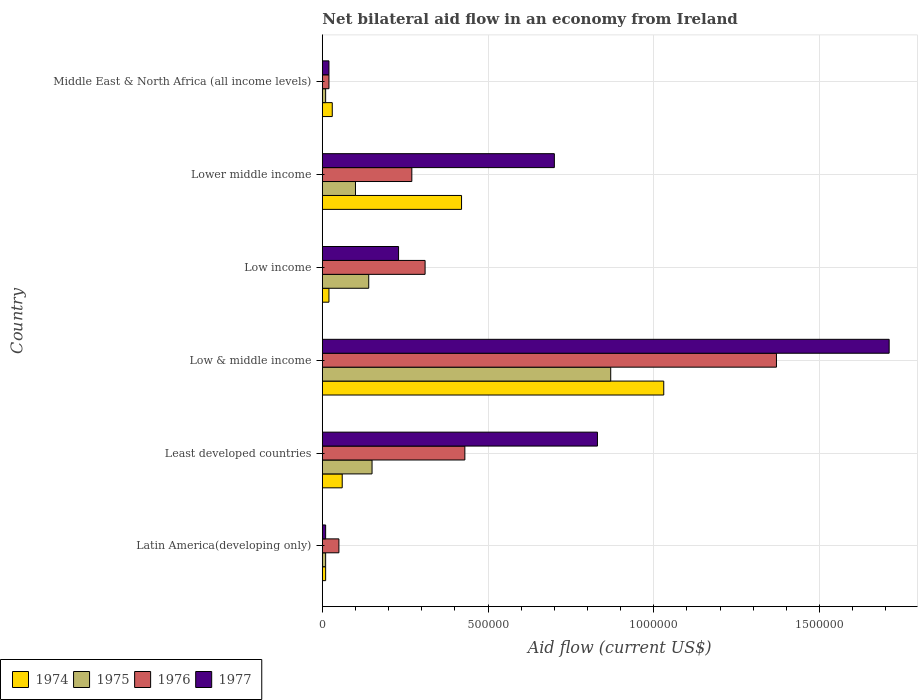How many different coloured bars are there?
Your response must be concise. 4. Are the number of bars per tick equal to the number of legend labels?
Your answer should be compact. Yes. How many bars are there on the 1st tick from the bottom?
Make the answer very short. 4. What is the label of the 1st group of bars from the top?
Keep it short and to the point. Middle East & North Africa (all income levels). In how many cases, is the number of bars for a given country not equal to the number of legend labels?
Offer a very short reply. 0. What is the net bilateral aid flow in 1976 in Middle East & North Africa (all income levels)?
Ensure brevity in your answer.  2.00e+04. Across all countries, what is the maximum net bilateral aid flow in 1975?
Keep it short and to the point. 8.70e+05. Across all countries, what is the minimum net bilateral aid flow in 1977?
Make the answer very short. 10000. In which country was the net bilateral aid flow in 1974 minimum?
Your answer should be compact. Latin America(developing only). What is the total net bilateral aid flow in 1976 in the graph?
Ensure brevity in your answer.  2.45e+06. What is the difference between the net bilateral aid flow in 1974 in Latin America(developing only) and that in Lower middle income?
Your response must be concise. -4.10e+05. What is the average net bilateral aid flow in 1975 per country?
Your answer should be compact. 2.13e+05. What is the difference between the net bilateral aid flow in 1974 and net bilateral aid flow in 1977 in Lower middle income?
Your answer should be very brief. -2.80e+05. In how many countries, is the net bilateral aid flow in 1976 greater than 400000 US$?
Provide a short and direct response. 2. What is the ratio of the net bilateral aid flow in 1974 in Low income to that in Lower middle income?
Make the answer very short. 0.05. Is the net bilateral aid flow in 1976 in Latin America(developing only) less than that in Low & middle income?
Your answer should be compact. Yes. What is the difference between the highest and the second highest net bilateral aid flow in 1977?
Your response must be concise. 8.80e+05. What is the difference between the highest and the lowest net bilateral aid flow in 1975?
Ensure brevity in your answer.  8.60e+05. In how many countries, is the net bilateral aid flow in 1976 greater than the average net bilateral aid flow in 1976 taken over all countries?
Your response must be concise. 2. Is it the case that in every country, the sum of the net bilateral aid flow in 1975 and net bilateral aid flow in 1977 is greater than the sum of net bilateral aid flow in 1976 and net bilateral aid flow in 1974?
Provide a succinct answer. No. What does the 2nd bar from the bottom in Latin America(developing only) represents?
Provide a short and direct response. 1975. How many bars are there?
Make the answer very short. 24. Are all the bars in the graph horizontal?
Your answer should be compact. Yes. What is the difference between two consecutive major ticks on the X-axis?
Your answer should be compact. 5.00e+05. Are the values on the major ticks of X-axis written in scientific E-notation?
Keep it short and to the point. No. Does the graph contain any zero values?
Make the answer very short. No. Does the graph contain grids?
Give a very brief answer. Yes. What is the title of the graph?
Provide a short and direct response. Net bilateral aid flow in an economy from Ireland. What is the label or title of the X-axis?
Make the answer very short. Aid flow (current US$). What is the Aid flow (current US$) of 1974 in Latin America(developing only)?
Provide a succinct answer. 10000. What is the Aid flow (current US$) in 1976 in Latin America(developing only)?
Ensure brevity in your answer.  5.00e+04. What is the Aid flow (current US$) of 1975 in Least developed countries?
Offer a terse response. 1.50e+05. What is the Aid flow (current US$) of 1977 in Least developed countries?
Offer a terse response. 8.30e+05. What is the Aid flow (current US$) in 1974 in Low & middle income?
Provide a succinct answer. 1.03e+06. What is the Aid flow (current US$) in 1975 in Low & middle income?
Offer a terse response. 8.70e+05. What is the Aid flow (current US$) in 1976 in Low & middle income?
Your response must be concise. 1.37e+06. What is the Aid flow (current US$) in 1977 in Low & middle income?
Keep it short and to the point. 1.71e+06. What is the Aid flow (current US$) of 1974 in Low income?
Offer a terse response. 2.00e+04. What is the Aid flow (current US$) of 1975 in Low income?
Provide a short and direct response. 1.40e+05. What is the Aid flow (current US$) in 1976 in Low income?
Offer a terse response. 3.10e+05. What is the Aid flow (current US$) in 1977 in Low income?
Your answer should be very brief. 2.30e+05. What is the Aid flow (current US$) in 1974 in Lower middle income?
Your answer should be very brief. 4.20e+05. What is the Aid flow (current US$) of 1975 in Lower middle income?
Your response must be concise. 1.00e+05. What is the Aid flow (current US$) of 1975 in Middle East & North Africa (all income levels)?
Your answer should be compact. 10000. What is the Aid flow (current US$) of 1976 in Middle East & North Africa (all income levels)?
Your response must be concise. 2.00e+04. Across all countries, what is the maximum Aid flow (current US$) in 1974?
Provide a succinct answer. 1.03e+06. Across all countries, what is the maximum Aid flow (current US$) of 1975?
Your answer should be compact. 8.70e+05. Across all countries, what is the maximum Aid flow (current US$) of 1976?
Your response must be concise. 1.37e+06. Across all countries, what is the maximum Aid flow (current US$) of 1977?
Ensure brevity in your answer.  1.71e+06. Across all countries, what is the minimum Aid flow (current US$) in 1974?
Provide a succinct answer. 10000. Across all countries, what is the minimum Aid flow (current US$) of 1976?
Provide a short and direct response. 2.00e+04. What is the total Aid flow (current US$) in 1974 in the graph?
Your response must be concise. 1.57e+06. What is the total Aid flow (current US$) of 1975 in the graph?
Provide a succinct answer. 1.28e+06. What is the total Aid flow (current US$) of 1976 in the graph?
Ensure brevity in your answer.  2.45e+06. What is the total Aid flow (current US$) of 1977 in the graph?
Your response must be concise. 3.50e+06. What is the difference between the Aid flow (current US$) in 1974 in Latin America(developing only) and that in Least developed countries?
Offer a very short reply. -5.00e+04. What is the difference between the Aid flow (current US$) of 1976 in Latin America(developing only) and that in Least developed countries?
Provide a succinct answer. -3.80e+05. What is the difference between the Aid flow (current US$) in 1977 in Latin America(developing only) and that in Least developed countries?
Offer a terse response. -8.20e+05. What is the difference between the Aid flow (current US$) of 1974 in Latin America(developing only) and that in Low & middle income?
Provide a succinct answer. -1.02e+06. What is the difference between the Aid flow (current US$) in 1975 in Latin America(developing only) and that in Low & middle income?
Offer a terse response. -8.60e+05. What is the difference between the Aid flow (current US$) of 1976 in Latin America(developing only) and that in Low & middle income?
Offer a terse response. -1.32e+06. What is the difference between the Aid flow (current US$) in 1977 in Latin America(developing only) and that in Low & middle income?
Offer a terse response. -1.70e+06. What is the difference between the Aid flow (current US$) of 1974 in Latin America(developing only) and that in Low income?
Offer a very short reply. -10000. What is the difference between the Aid flow (current US$) of 1974 in Latin America(developing only) and that in Lower middle income?
Your answer should be very brief. -4.10e+05. What is the difference between the Aid flow (current US$) of 1977 in Latin America(developing only) and that in Lower middle income?
Keep it short and to the point. -6.90e+05. What is the difference between the Aid flow (current US$) in 1975 in Latin America(developing only) and that in Middle East & North Africa (all income levels)?
Your response must be concise. 0. What is the difference between the Aid flow (current US$) in 1976 in Latin America(developing only) and that in Middle East & North Africa (all income levels)?
Provide a short and direct response. 3.00e+04. What is the difference between the Aid flow (current US$) of 1977 in Latin America(developing only) and that in Middle East & North Africa (all income levels)?
Offer a terse response. -10000. What is the difference between the Aid flow (current US$) of 1974 in Least developed countries and that in Low & middle income?
Give a very brief answer. -9.70e+05. What is the difference between the Aid flow (current US$) of 1975 in Least developed countries and that in Low & middle income?
Provide a succinct answer. -7.20e+05. What is the difference between the Aid flow (current US$) in 1976 in Least developed countries and that in Low & middle income?
Ensure brevity in your answer.  -9.40e+05. What is the difference between the Aid flow (current US$) of 1977 in Least developed countries and that in Low & middle income?
Offer a very short reply. -8.80e+05. What is the difference between the Aid flow (current US$) of 1975 in Least developed countries and that in Low income?
Provide a short and direct response. 10000. What is the difference between the Aid flow (current US$) in 1974 in Least developed countries and that in Lower middle income?
Your answer should be compact. -3.60e+05. What is the difference between the Aid flow (current US$) in 1976 in Least developed countries and that in Lower middle income?
Keep it short and to the point. 1.60e+05. What is the difference between the Aid flow (current US$) of 1977 in Least developed countries and that in Lower middle income?
Your answer should be compact. 1.30e+05. What is the difference between the Aid flow (current US$) of 1977 in Least developed countries and that in Middle East & North Africa (all income levels)?
Your response must be concise. 8.10e+05. What is the difference between the Aid flow (current US$) of 1974 in Low & middle income and that in Low income?
Make the answer very short. 1.01e+06. What is the difference between the Aid flow (current US$) of 1975 in Low & middle income and that in Low income?
Your response must be concise. 7.30e+05. What is the difference between the Aid flow (current US$) in 1976 in Low & middle income and that in Low income?
Keep it short and to the point. 1.06e+06. What is the difference between the Aid flow (current US$) of 1977 in Low & middle income and that in Low income?
Keep it short and to the point. 1.48e+06. What is the difference between the Aid flow (current US$) in 1975 in Low & middle income and that in Lower middle income?
Give a very brief answer. 7.70e+05. What is the difference between the Aid flow (current US$) in 1976 in Low & middle income and that in Lower middle income?
Offer a terse response. 1.10e+06. What is the difference between the Aid flow (current US$) in 1977 in Low & middle income and that in Lower middle income?
Keep it short and to the point. 1.01e+06. What is the difference between the Aid flow (current US$) in 1974 in Low & middle income and that in Middle East & North Africa (all income levels)?
Make the answer very short. 1.00e+06. What is the difference between the Aid flow (current US$) in 1975 in Low & middle income and that in Middle East & North Africa (all income levels)?
Your answer should be compact. 8.60e+05. What is the difference between the Aid flow (current US$) of 1976 in Low & middle income and that in Middle East & North Africa (all income levels)?
Ensure brevity in your answer.  1.35e+06. What is the difference between the Aid flow (current US$) of 1977 in Low & middle income and that in Middle East & North Africa (all income levels)?
Your response must be concise. 1.69e+06. What is the difference between the Aid flow (current US$) in 1974 in Low income and that in Lower middle income?
Provide a succinct answer. -4.00e+05. What is the difference between the Aid flow (current US$) of 1977 in Low income and that in Lower middle income?
Your answer should be very brief. -4.70e+05. What is the difference between the Aid flow (current US$) of 1974 in Low income and that in Middle East & North Africa (all income levels)?
Make the answer very short. -10000. What is the difference between the Aid flow (current US$) of 1976 in Low income and that in Middle East & North Africa (all income levels)?
Provide a succinct answer. 2.90e+05. What is the difference between the Aid flow (current US$) in 1975 in Lower middle income and that in Middle East & North Africa (all income levels)?
Offer a very short reply. 9.00e+04. What is the difference between the Aid flow (current US$) of 1976 in Lower middle income and that in Middle East & North Africa (all income levels)?
Provide a succinct answer. 2.50e+05. What is the difference between the Aid flow (current US$) of 1977 in Lower middle income and that in Middle East & North Africa (all income levels)?
Ensure brevity in your answer.  6.80e+05. What is the difference between the Aid flow (current US$) of 1974 in Latin America(developing only) and the Aid flow (current US$) of 1975 in Least developed countries?
Your response must be concise. -1.40e+05. What is the difference between the Aid flow (current US$) of 1974 in Latin America(developing only) and the Aid flow (current US$) of 1976 in Least developed countries?
Ensure brevity in your answer.  -4.20e+05. What is the difference between the Aid flow (current US$) in 1974 in Latin America(developing only) and the Aid flow (current US$) in 1977 in Least developed countries?
Your response must be concise. -8.20e+05. What is the difference between the Aid flow (current US$) of 1975 in Latin America(developing only) and the Aid flow (current US$) of 1976 in Least developed countries?
Ensure brevity in your answer.  -4.20e+05. What is the difference between the Aid flow (current US$) in 1975 in Latin America(developing only) and the Aid flow (current US$) in 1977 in Least developed countries?
Make the answer very short. -8.20e+05. What is the difference between the Aid flow (current US$) in 1976 in Latin America(developing only) and the Aid flow (current US$) in 1977 in Least developed countries?
Offer a terse response. -7.80e+05. What is the difference between the Aid flow (current US$) in 1974 in Latin America(developing only) and the Aid flow (current US$) in 1975 in Low & middle income?
Your answer should be very brief. -8.60e+05. What is the difference between the Aid flow (current US$) in 1974 in Latin America(developing only) and the Aid flow (current US$) in 1976 in Low & middle income?
Your answer should be very brief. -1.36e+06. What is the difference between the Aid flow (current US$) in 1974 in Latin America(developing only) and the Aid flow (current US$) in 1977 in Low & middle income?
Offer a terse response. -1.70e+06. What is the difference between the Aid flow (current US$) in 1975 in Latin America(developing only) and the Aid flow (current US$) in 1976 in Low & middle income?
Give a very brief answer. -1.36e+06. What is the difference between the Aid flow (current US$) in 1975 in Latin America(developing only) and the Aid flow (current US$) in 1977 in Low & middle income?
Your response must be concise. -1.70e+06. What is the difference between the Aid flow (current US$) of 1976 in Latin America(developing only) and the Aid flow (current US$) of 1977 in Low & middle income?
Give a very brief answer. -1.66e+06. What is the difference between the Aid flow (current US$) in 1974 in Latin America(developing only) and the Aid flow (current US$) in 1975 in Low income?
Provide a short and direct response. -1.30e+05. What is the difference between the Aid flow (current US$) in 1975 in Latin America(developing only) and the Aid flow (current US$) in 1976 in Low income?
Ensure brevity in your answer.  -3.00e+05. What is the difference between the Aid flow (current US$) in 1974 in Latin America(developing only) and the Aid flow (current US$) in 1975 in Lower middle income?
Keep it short and to the point. -9.00e+04. What is the difference between the Aid flow (current US$) of 1974 in Latin America(developing only) and the Aid flow (current US$) of 1977 in Lower middle income?
Provide a short and direct response. -6.90e+05. What is the difference between the Aid flow (current US$) of 1975 in Latin America(developing only) and the Aid flow (current US$) of 1977 in Lower middle income?
Give a very brief answer. -6.90e+05. What is the difference between the Aid flow (current US$) in 1976 in Latin America(developing only) and the Aid flow (current US$) in 1977 in Lower middle income?
Ensure brevity in your answer.  -6.50e+05. What is the difference between the Aid flow (current US$) of 1974 in Latin America(developing only) and the Aid flow (current US$) of 1976 in Middle East & North Africa (all income levels)?
Your response must be concise. -10000. What is the difference between the Aid flow (current US$) in 1974 in Latin America(developing only) and the Aid flow (current US$) in 1977 in Middle East & North Africa (all income levels)?
Your answer should be very brief. -10000. What is the difference between the Aid flow (current US$) in 1975 in Latin America(developing only) and the Aid flow (current US$) in 1976 in Middle East & North Africa (all income levels)?
Ensure brevity in your answer.  -10000. What is the difference between the Aid flow (current US$) of 1975 in Latin America(developing only) and the Aid flow (current US$) of 1977 in Middle East & North Africa (all income levels)?
Your answer should be compact. -10000. What is the difference between the Aid flow (current US$) of 1976 in Latin America(developing only) and the Aid flow (current US$) of 1977 in Middle East & North Africa (all income levels)?
Ensure brevity in your answer.  3.00e+04. What is the difference between the Aid flow (current US$) in 1974 in Least developed countries and the Aid flow (current US$) in 1975 in Low & middle income?
Keep it short and to the point. -8.10e+05. What is the difference between the Aid flow (current US$) in 1974 in Least developed countries and the Aid flow (current US$) in 1976 in Low & middle income?
Offer a terse response. -1.31e+06. What is the difference between the Aid flow (current US$) of 1974 in Least developed countries and the Aid flow (current US$) of 1977 in Low & middle income?
Offer a very short reply. -1.65e+06. What is the difference between the Aid flow (current US$) of 1975 in Least developed countries and the Aid flow (current US$) of 1976 in Low & middle income?
Provide a short and direct response. -1.22e+06. What is the difference between the Aid flow (current US$) of 1975 in Least developed countries and the Aid flow (current US$) of 1977 in Low & middle income?
Your answer should be very brief. -1.56e+06. What is the difference between the Aid flow (current US$) of 1976 in Least developed countries and the Aid flow (current US$) of 1977 in Low & middle income?
Your answer should be compact. -1.28e+06. What is the difference between the Aid flow (current US$) in 1974 in Least developed countries and the Aid flow (current US$) in 1976 in Low income?
Offer a very short reply. -2.50e+05. What is the difference between the Aid flow (current US$) of 1975 in Least developed countries and the Aid flow (current US$) of 1976 in Low income?
Your answer should be very brief. -1.60e+05. What is the difference between the Aid flow (current US$) of 1974 in Least developed countries and the Aid flow (current US$) of 1975 in Lower middle income?
Your answer should be very brief. -4.00e+04. What is the difference between the Aid flow (current US$) in 1974 in Least developed countries and the Aid flow (current US$) in 1976 in Lower middle income?
Keep it short and to the point. -2.10e+05. What is the difference between the Aid flow (current US$) of 1974 in Least developed countries and the Aid flow (current US$) of 1977 in Lower middle income?
Provide a short and direct response. -6.40e+05. What is the difference between the Aid flow (current US$) of 1975 in Least developed countries and the Aid flow (current US$) of 1976 in Lower middle income?
Offer a terse response. -1.20e+05. What is the difference between the Aid flow (current US$) in 1975 in Least developed countries and the Aid flow (current US$) in 1977 in Lower middle income?
Provide a succinct answer. -5.50e+05. What is the difference between the Aid flow (current US$) of 1976 in Least developed countries and the Aid flow (current US$) of 1977 in Lower middle income?
Provide a short and direct response. -2.70e+05. What is the difference between the Aid flow (current US$) of 1974 in Least developed countries and the Aid flow (current US$) of 1976 in Middle East & North Africa (all income levels)?
Your response must be concise. 4.00e+04. What is the difference between the Aid flow (current US$) in 1974 in Least developed countries and the Aid flow (current US$) in 1977 in Middle East & North Africa (all income levels)?
Make the answer very short. 4.00e+04. What is the difference between the Aid flow (current US$) in 1976 in Least developed countries and the Aid flow (current US$) in 1977 in Middle East & North Africa (all income levels)?
Make the answer very short. 4.10e+05. What is the difference between the Aid flow (current US$) in 1974 in Low & middle income and the Aid flow (current US$) in 1975 in Low income?
Your answer should be very brief. 8.90e+05. What is the difference between the Aid flow (current US$) in 1974 in Low & middle income and the Aid flow (current US$) in 1976 in Low income?
Keep it short and to the point. 7.20e+05. What is the difference between the Aid flow (current US$) of 1975 in Low & middle income and the Aid flow (current US$) of 1976 in Low income?
Your answer should be compact. 5.60e+05. What is the difference between the Aid flow (current US$) in 1975 in Low & middle income and the Aid flow (current US$) in 1977 in Low income?
Your response must be concise. 6.40e+05. What is the difference between the Aid flow (current US$) of 1976 in Low & middle income and the Aid flow (current US$) of 1977 in Low income?
Make the answer very short. 1.14e+06. What is the difference between the Aid flow (current US$) in 1974 in Low & middle income and the Aid flow (current US$) in 1975 in Lower middle income?
Provide a succinct answer. 9.30e+05. What is the difference between the Aid flow (current US$) of 1974 in Low & middle income and the Aid flow (current US$) of 1976 in Lower middle income?
Give a very brief answer. 7.60e+05. What is the difference between the Aid flow (current US$) in 1974 in Low & middle income and the Aid flow (current US$) in 1977 in Lower middle income?
Offer a very short reply. 3.30e+05. What is the difference between the Aid flow (current US$) in 1975 in Low & middle income and the Aid flow (current US$) in 1976 in Lower middle income?
Ensure brevity in your answer.  6.00e+05. What is the difference between the Aid flow (current US$) of 1976 in Low & middle income and the Aid flow (current US$) of 1977 in Lower middle income?
Provide a short and direct response. 6.70e+05. What is the difference between the Aid flow (current US$) of 1974 in Low & middle income and the Aid flow (current US$) of 1975 in Middle East & North Africa (all income levels)?
Give a very brief answer. 1.02e+06. What is the difference between the Aid flow (current US$) of 1974 in Low & middle income and the Aid flow (current US$) of 1976 in Middle East & North Africa (all income levels)?
Offer a very short reply. 1.01e+06. What is the difference between the Aid flow (current US$) of 1974 in Low & middle income and the Aid flow (current US$) of 1977 in Middle East & North Africa (all income levels)?
Your answer should be very brief. 1.01e+06. What is the difference between the Aid flow (current US$) in 1975 in Low & middle income and the Aid flow (current US$) in 1976 in Middle East & North Africa (all income levels)?
Provide a succinct answer. 8.50e+05. What is the difference between the Aid flow (current US$) in 1975 in Low & middle income and the Aid flow (current US$) in 1977 in Middle East & North Africa (all income levels)?
Provide a succinct answer. 8.50e+05. What is the difference between the Aid flow (current US$) in 1976 in Low & middle income and the Aid flow (current US$) in 1977 in Middle East & North Africa (all income levels)?
Offer a terse response. 1.35e+06. What is the difference between the Aid flow (current US$) of 1974 in Low income and the Aid flow (current US$) of 1977 in Lower middle income?
Give a very brief answer. -6.80e+05. What is the difference between the Aid flow (current US$) of 1975 in Low income and the Aid flow (current US$) of 1976 in Lower middle income?
Your answer should be very brief. -1.30e+05. What is the difference between the Aid flow (current US$) of 1975 in Low income and the Aid flow (current US$) of 1977 in Lower middle income?
Provide a short and direct response. -5.60e+05. What is the difference between the Aid flow (current US$) in 1976 in Low income and the Aid flow (current US$) in 1977 in Lower middle income?
Your answer should be compact. -3.90e+05. What is the difference between the Aid flow (current US$) of 1974 in Low income and the Aid flow (current US$) of 1975 in Middle East & North Africa (all income levels)?
Ensure brevity in your answer.  10000. What is the difference between the Aid flow (current US$) in 1974 in Low income and the Aid flow (current US$) in 1976 in Middle East & North Africa (all income levels)?
Keep it short and to the point. 0. What is the difference between the Aid flow (current US$) of 1974 in Low income and the Aid flow (current US$) of 1977 in Middle East & North Africa (all income levels)?
Keep it short and to the point. 0. What is the difference between the Aid flow (current US$) of 1975 in Low income and the Aid flow (current US$) of 1976 in Middle East & North Africa (all income levels)?
Give a very brief answer. 1.20e+05. What is the difference between the Aid flow (current US$) in 1976 in Low income and the Aid flow (current US$) in 1977 in Middle East & North Africa (all income levels)?
Your answer should be compact. 2.90e+05. What is the difference between the Aid flow (current US$) in 1974 in Lower middle income and the Aid flow (current US$) in 1977 in Middle East & North Africa (all income levels)?
Your answer should be very brief. 4.00e+05. What is the difference between the Aid flow (current US$) of 1975 in Lower middle income and the Aid flow (current US$) of 1976 in Middle East & North Africa (all income levels)?
Make the answer very short. 8.00e+04. What is the average Aid flow (current US$) of 1974 per country?
Give a very brief answer. 2.62e+05. What is the average Aid flow (current US$) in 1975 per country?
Your answer should be very brief. 2.13e+05. What is the average Aid flow (current US$) in 1976 per country?
Provide a succinct answer. 4.08e+05. What is the average Aid flow (current US$) of 1977 per country?
Provide a short and direct response. 5.83e+05. What is the difference between the Aid flow (current US$) of 1974 and Aid flow (current US$) of 1976 in Latin America(developing only)?
Offer a very short reply. -4.00e+04. What is the difference between the Aid flow (current US$) in 1974 and Aid flow (current US$) in 1977 in Latin America(developing only)?
Ensure brevity in your answer.  0. What is the difference between the Aid flow (current US$) in 1976 and Aid flow (current US$) in 1977 in Latin America(developing only)?
Provide a succinct answer. 4.00e+04. What is the difference between the Aid flow (current US$) in 1974 and Aid flow (current US$) in 1975 in Least developed countries?
Offer a very short reply. -9.00e+04. What is the difference between the Aid flow (current US$) of 1974 and Aid flow (current US$) of 1976 in Least developed countries?
Keep it short and to the point. -3.70e+05. What is the difference between the Aid flow (current US$) in 1974 and Aid flow (current US$) in 1977 in Least developed countries?
Offer a very short reply. -7.70e+05. What is the difference between the Aid flow (current US$) of 1975 and Aid flow (current US$) of 1976 in Least developed countries?
Provide a short and direct response. -2.80e+05. What is the difference between the Aid flow (current US$) of 1975 and Aid flow (current US$) of 1977 in Least developed countries?
Ensure brevity in your answer.  -6.80e+05. What is the difference between the Aid flow (current US$) in 1976 and Aid flow (current US$) in 1977 in Least developed countries?
Your answer should be very brief. -4.00e+05. What is the difference between the Aid flow (current US$) of 1974 and Aid flow (current US$) of 1975 in Low & middle income?
Your response must be concise. 1.60e+05. What is the difference between the Aid flow (current US$) of 1974 and Aid flow (current US$) of 1977 in Low & middle income?
Your answer should be very brief. -6.80e+05. What is the difference between the Aid flow (current US$) in 1975 and Aid flow (current US$) in 1976 in Low & middle income?
Keep it short and to the point. -5.00e+05. What is the difference between the Aid flow (current US$) of 1975 and Aid flow (current US$) of 1977 in Low & middle income?
Keep it short and to the point. -8.40e+05. What is the difference between the Aid flow (current US$) in 1974 and Aid flow (current US$) in 1975 in Low income?
Ensure brevity in your answer.  -1.20e+05. What is the difference between the Aid flow (current US$) of 1975 and Aid flow (current US$) of 1976 in Low income?
Offer a very short reply. -1.70e+05. What is the difference between the Aid flow (current US$) of 1975 and Aid flow (current US$) of 1977 in Low income?
Provide a short and direct response. -9.00e+04. What is the difference between the Aid flow (current US$) in 1976 and Aid flow (current US$) in 1977 in Low income?
Your response must be concise. 8.00e+04. What is the difference between the Aid flow (current US$) of 1974 and Aid flow (current US$) of 1975 in Lower middle income?
Your answer should be very brief. 3.20e+05. What is the difference between the Aid flow (current US$) in 1974 and Aid flow (current US$) in 1976 in Lower middle income?
Ensure brevity in your answer.  1.50e+05. What is the difference between the Aid flow (current US$) of 1974 and Aid flow (current US$) of 1977 in Lower middle income?
Keep it short and to the point. -2.80e+05. What is the difference between the Aid flow (current US$) of 1975 and Aid flow (current US$) of 1976 in Lower middle income?
Make the answer very short. -1.70e+05. What is the difference between the Aid flow (current US$) of 1975 and Aid flow (current US$) of 1977 in Lower middle income?
Ensure brevity in your answer.  -6.00e+05. What is the difference between the Aid flow (current US$) in 1976 and Aid flow (current US$) in 1977 in Lower middle income?
Your answer should be compact. -4.30e+05. What is the difference between the Aid flow (current US$) in 1974 and Aid flow (current US$) in 1977 in Middle East & North Africa (all income levels)?
Offer a very short reply. 10000. What is the difference between the Aid flow (current US$) of 1976 and Aid flow (current US$) of 1977 in Middle East & North Africa (all income levels)?
Ensure brevity in your answer.  0. What is the ratio of the Aid flow (current US$) of 1975 in Latin America(developing only) to that in Least developed countries?
Your answer should be very brief. 0.07. What is the ratio of the Aid flow (current US$) in 1976 in Latin America(developing only) to that in Least developed countries?
Provide a succinct answer. 0.12. What is the ratio of the Aid flow (current US$) of 1977 in Latin America(developing only) to that in Least developed countries?
Provide a succinct answer. 0.01. What is the ratio of the Aid flow (current US$) in 1974 in Latin America(developing only) to that in Low & middle income?
Your response must be concise. 0.01. What is the ratio of the Aid flow (current US$) in 1975 in Latin America(developing only) to that in Low & middle income?
Give a very brief answer. 0.01. What is the ratio of the Aid flow (current US$) of 1976 in Latin America(developing only) to that in Low & middle income?
Your answer should be compact. 0.04. What is the ratio of the Aid flow (current US$) of 1977 in Latin America(developing only) to that in Low & middle income?
Offer a very short reply. 0.01. What is the ratio of the Aid flow (current US$) in 1974 in Latin America(developing only) to that in Low income?
Provide a succinct answer. 0.5. What is the ratio of the Aid flow (current US$) of 1975 in Latin America(developing only) to that in Low income?
Your response must be concise. 0.07. What is the ratio of the Aid flow (current US$) in 1976 in Latin America(developing only) to that in Low income?
Provide a short and direct response. 0.16. What is the ratio of the Aid flow (current US$) of 1977 in Latin America(developing only) to that in Low income?
Make the answer very short. 0.04. What is the ratio of the Aid flow (current US$) of 1974 in Latin America(developing only) to that in Lower middle income?
Provide a short and direct response. 0.02. What is the ratio of the Aid flow (current US$) in 1976 in Latin America(developing only) to that in Lower middle income?
Provide a succinct answer. 0.19. What is the ratio of the Aid flow (current US$) of 1977 in Latin America(developing only) to that in Lower middle income?
Your answer should be compact. 0.01. What is the ratio of the Aid flow (current US$) in 1975 in Latin America(developing only) to that in Middle East & North Africa (all income levels)?
Make the answer very short. 1. What is the ratio of the Aid flow (current US$) of 1977 in Latin America(developing only) to that in Middle East & North Africa (all income levels)?
Ensure brevity in your answer.  0.5. What is the ratio of the Aid flow (current US$) in 1974 in Least developed countries to that in Low & middle income?
Your response must be concise. 0.06. What is the ratio of the Aid flow (current US$) in 1975 in Least developed countries to that in Low & middle income?
Provide a succinct answer. 0.17. What is the ratio of the Aid flow (current US$) of 1976 in Least developed countries to that in Low & middle income?
Provide a short and direct response. 0.31. What is the ratio of the Aid flow (current US$) of 1977 in Least developed countries to that in Low & middle income?
Your answer should be compact. 0.49. What is the ratio of the Aid flow (current US$) in 1975 in Least developed countries to that in Low income?
Ensure brevity in your answer.  1.07. What is the ratio of the Aid flow (current US$) of 1976 in Least developed countries to that in Low income?
Keep it short and to the point. 1.39. What is the ratio of the Aid flow (current US$) of 1977 in Least developed countries to that in Low income?
Ensure brevity in your answer.  3.61. What is the ratio of the Aid flow (current US$) in 1974 in Least developed countries to that in Lower middle income?
Offer a very short reply. 0.14. What is the ratio of the Aid flow (current US$) of 1975 in Least developed countries to that in Lower middle income?
Your answer should be compact. 1.5. What is the ratio of the Aid flow (current US$) of 1976 in Least developed countries to that in Lower middle income?
Your response must be concise. 1.59. What is the ratio of the Aid flow (current US$) of 1977 in Least developed countries to that in Lower middle income?
Keep it short and to the point. 1.19. What is the ratio of the Aid flow (current US$) in 1977 in Least developed countries to that in Middle East & North Africa (all income levels)?
Provide a short and direct response. 41.5. What is the ratio of the Aid flow (current US$) in 1974 in Low & middle income to that in Low income?
Give a very brief answer. 51.5. What is the ratio of the Aid flow (current US$) in 1975 in Low & middle income to that in Low income?
Keep it short and to the point. 6.21. What is the ratio of the Aid flow (current US$) of 1976 in Low & middle income to that in Low income?
Ensure brevity in your answer.  4.42. What is the ratio of the Aid flow (current US$) of 1977 in Low & middle income to that in Low income?
Give a very brief answer. 7.43. What is the ratio of the Aid flow (current US$) in 1974 in Low & middle income to that in Lower middle income?
Provide a succinct answer. 2.45. What is the ratio of the Aid flow (current US$) of 1975 in Low & middle income to that in Lower middle income?
Ensure brevity in your answer.  8.7. What is the ratio of the Aid flow (current US$) in 1976 in Low & middle income to that in Lower middle income?
Give a very brief answer. 5.07. What is the ratio of the Aid flow (current US$) in 1977 in Low & middle income to that in Lower middle income?
Give a very brief answer. 2.44. What is the ratio of the Aid flow (current US$) in 1974 in Low & middle income to that in Middle East & North Africa (all income levels)?
Offer a terse response. 34.33. What is the ratio of the Aid flow (current US$) in 1976 in Low & middle income to that in Middle East & North Africa (all income levels)?
Your answer should be very brief. 68.5. What is the ratio of the Aid flow (current US$) of 1977 in Low & middle income to that in Middle East & North Africa (all income levels)?
Give a very brief answer. 85.5. What is the ratio of the Aid flow (current US$) in 1974 in Low income to that in Lower middle income?
Your answer should be compact. 0.05. What is the ratio of the Aid flow (current US$) of 1976 in Low income to that in Lower middle income?
Your answer should be compact. 1.15. What is the ratio of the Aid flow (current US$) of 1977 in Low income to that in Lower middle income?
Provide a succinct answer. 0.33. What is the ratio of the Aid flow (current US$) in 1974 in Low income to that in Middle East & North Africa (all income levels)?
Offer a terse response. 0.67. What is the ratio of the Aid flow (current US$) in 1975 in Low income to that in Middle East & North Africa (all income levels)?
Provide a short and direct response. 14. What is the ratio of the Aid flow (current US$) of 1976 in Low income to that in Middle East & North Africa (all income levels)?
Your answer should be very brief. 15.5. What is the ratio of the Aid flow (current US$) in 1974 in Lower middle income to that in Middle East & North Africa (all income levels)?
Your answer should be very brief. 14. What is the ratio of the Aid flow (current US$) in 1975 in Lower middle income to that in Middle East & North Africa (all income levels)?
Your response must be concise. 10. What is the ratio of the Aid flow (current US$) of 1976 in Lower middle income to that in Middle East & North Africa (all income levels)?
Keep it short and to the point. 13.5. What is the difference between the highest and the second highest Aid flow (current US$) of 1975?
Offer a very short reply. 7.20e+05. What is the difference between the highest and the second highest Aid flow (current US$) of 1976?
Give a very brief answer. 9.40e+05. What is the difference between the highest and the second highest Aid flow (current US$) in 1977?
Keep it short and to the point. 8.80e+05. What is the difference between the highest and the lowest Aid flow (current US$) of 1974?
Ensure brevity in your answer.  1.02e+06. What is the difference between the highest and the lowest Aid flow (current US$) of 1975?
Offer a terse response. 8.60e+05. What is the difference between the highest and the lowest Aid flow (current US$) in 1976?
Give a very brief answer. 1.35e+06. What is the difference between the highest and the lowest Aid flow (current US$) in 1977?
Your answer should be very brief. 1.70e+06. 